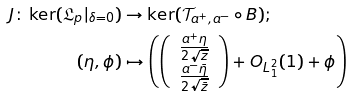<formula> <loc_0><loc_0><loc_500><loc_500>J \colon \ker ( \mathfrak { L } _ { p } | _ { \delta = 0 } ) & \rightarrow \ker ( \mathcal { T } _ { a ^ { + } , a ^ { - } } \circ B ) ; \\ ( \eta , \phi ) & \mapsto \left ( \left ( \begin{array} { c } \frac { a ^ { + } \eta } { 2 \sqrt { z } } \\ \frac { a ^ { - } \bar { \eta } } { 2 \sqrt { \bar { z } } } \end{array} \right ) + O _ { L ^ { 2 } _ { 1 } } ( 1 ) + \phi \right )</formula> 